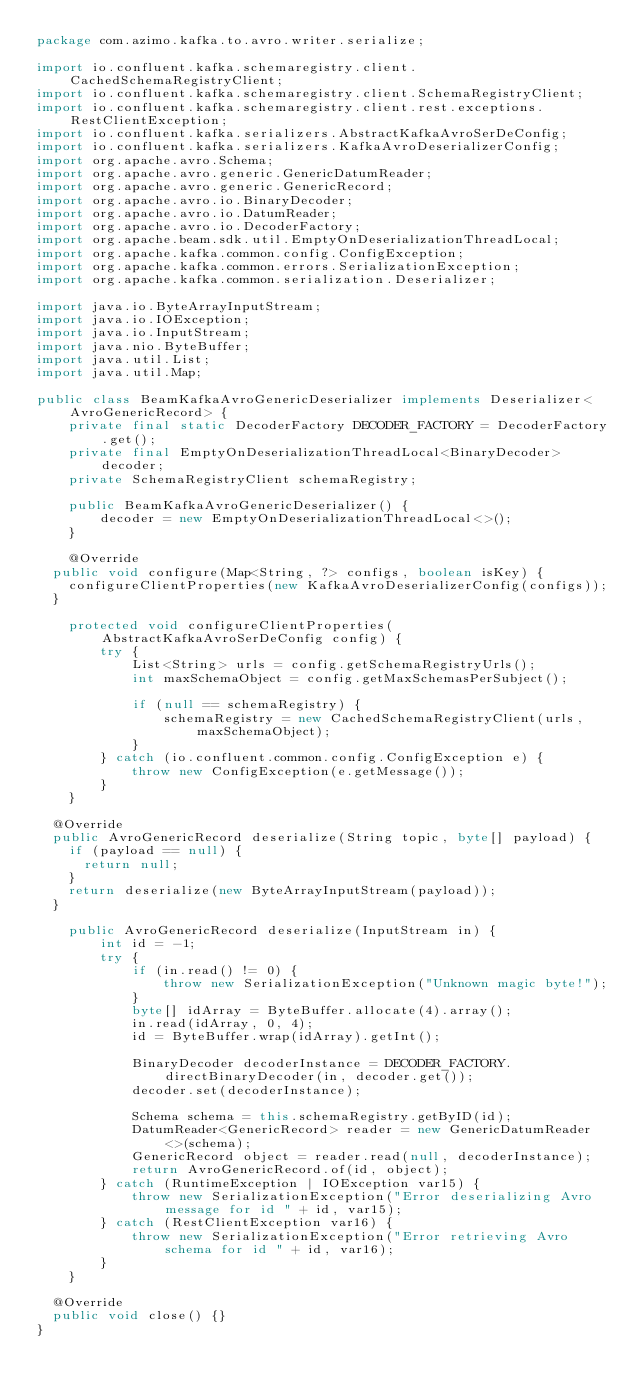Convert code to text. <code><loc_0><loc_0><loc_500><loc_500><_Java_>package com.azimo.kafka.to.avro.writer.serialize;

import io.confluent.kafka.schemaregistry.client.CachedSchemaRegistryClient;
import io.confluent.kafka.schemaregistry.client.SchemaRegistryClient;
import io.confluent.kafka.schemaregistry.client.rest.exceptions.RestClientException;
import io.confluent.kafka.serializers.AbstractKafkaAvroSerDeConfig;
import io.confluent.kafka.serializers.KafkaAvroDeserializerConfig;
import org.apache.avro.Schema;
import org.apache.avro.generic.GenericDatumReader;
import org.apache.avro.generic.GenericRecord;
import org.apache.avro.io.BinaryDecoder;
import org.apache.avro.io.DatumReader;
import org.apache.avro.io.DecoderFactory;
import org.apache.beam.sdk.util.EmptyOnDeserializationThreadLocal;
import org.apache.kafka.common.config.ConfigException;
import org.apache.kafka.common.errors.SerializationException;
import org.apache.kafka.common.serialization.Deserializer;

import java.io.ByteArrayInputStream;
import java.io.IOException;
import java.io.InputStream;
import java.nio.ByteBuffer;
import java.util.List;
import java.util.Map;

public class BeamKafkaAvroGenericDeserializer implements Deserializer<AvroGenericRecord> {
    private final static DecoderFactory DECODER_FACTORY = DecoderFactory.get();
    private final EmptyOnDeserializationThreadLocal<BinaryDecoder> decoder;
    private SchemaRegistryClient schemaRegistry;

    public BeamKafkaAvroGenericDeserializer() {
        decoder = new EmptyOnDeserializationThreadLocal<>();
    }

    @Override
	public void configure(Map<String, ?> configs, boolean isKey) {
		configureClientProperties(new KafkaAvroDeserializerConfig(configs));
	}

    protected void configureClientProperties(AbstractKafkaAvroSerDeConfig config) {
        try {
            List<String> urls = config.getSchemaRegistryUrls();
            int maxSchemaObject = config.getMaxSchemasPerSubject();

            if (null == schemaRegistry) {
                schemaRegistry = new CachedSchemaRegistryClient(urls, maxSchemaObject);
            }
        } catch (io.confluent.common.config.ConfigException e) {
            throw new ConfigException(e.getMessage());
        }
    }

	@Override
	public AvroGenericRecord deserialize(String topic, byte[] payload) {
		if (payload == null) {
			return null;
		}
		return deserialize(new ByteArrayInputStream(payload));
	}

    public AvroGenericRecord deserialize(InputStream in) {
        int id = -1;
        try {
            if (in.read() != 0) {
                throw new SerializationException("Unknown magic byte!");
            }
            byte[] idArray = ByteBuffer.allocate(4).array();
            in.read(idArray, 0, 4);
            id = ByteBuffer.wrap(idArray).getInt();

            BinaryDecoder decoderInstance = DECODER_FACTORY.directBinaryDecoder(in, decoder.get());
            decoder.set(decoderInstance);

            Schema schema = this.schemaRegistry.getByID(id);
            DatumReader<GenericRecord> reader = new GenericDatumReader<>(schema);
            GenericRecord object = reader.read(null, decoderInstance);
            return AvroGenericRecord.of(id, object);
        } catch (RuntimeException | IOException var15) {
            throw new SerializationException("Error deserializing Avro message for id " + id, var15);
        } catch (RestClientException var16) {
            throw new SerializationException("Error retrieving Avro schema for id " + id, var16);
        }
    }

	@Override
	public void close() {}
}
</code> 